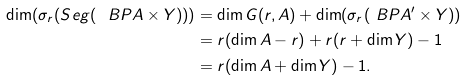Convert formula to latex. <formula><loc_0><loc_0><loc_500><loc_500>\dim ( \sigma _ { r } ( S e g ( \ B P A \times Y ) ) ) & = \dim G ( r , A ) + \dim ( \sigma _ { r } ( \ B P A ^ { \prime } \times Y ) ) \\ & = r ( \dim A - r ) + r ( r + \dim Y ) - 1 \\ & = r ( \dim A + \dim Y ) - 1 .</formula> 